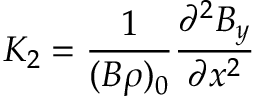<formula> <loc_0><loc_0><loc_500><loc_500>K _ { 2 } = \frac { 1 } { ( B \rho ) _ { 0 } } \frac { \partial ^ { 2 } B _ { y } } { \partial x ^ { 2 } }</formula> 